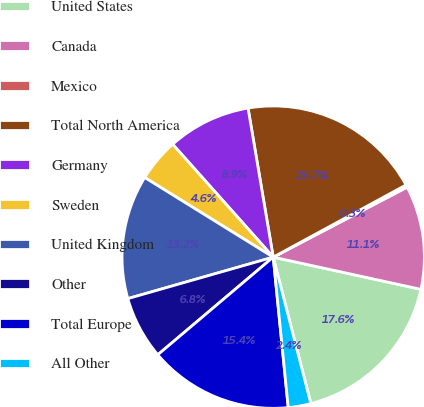Convert chart. <chart><loc_0><loc_0><loc_500><loc_500><pie_chart><fcel>United States<fcel>Canada<fcel>Mexico<fcel>Total North America<fcel>Germany<fcel>Sweden<fcel>United Kingdom<fcel>Other<fcel>Total Europe<fcel>All Other<nl><fcel>17.58%<fcel>11.08%<fcel>0.26%<fcel>19.74%<fcel>8.92%<fcel>4.59%<fcel>13.25%<fcel>6.75%<fcel>15.41%<fcel>2.42%<nl></chart> 